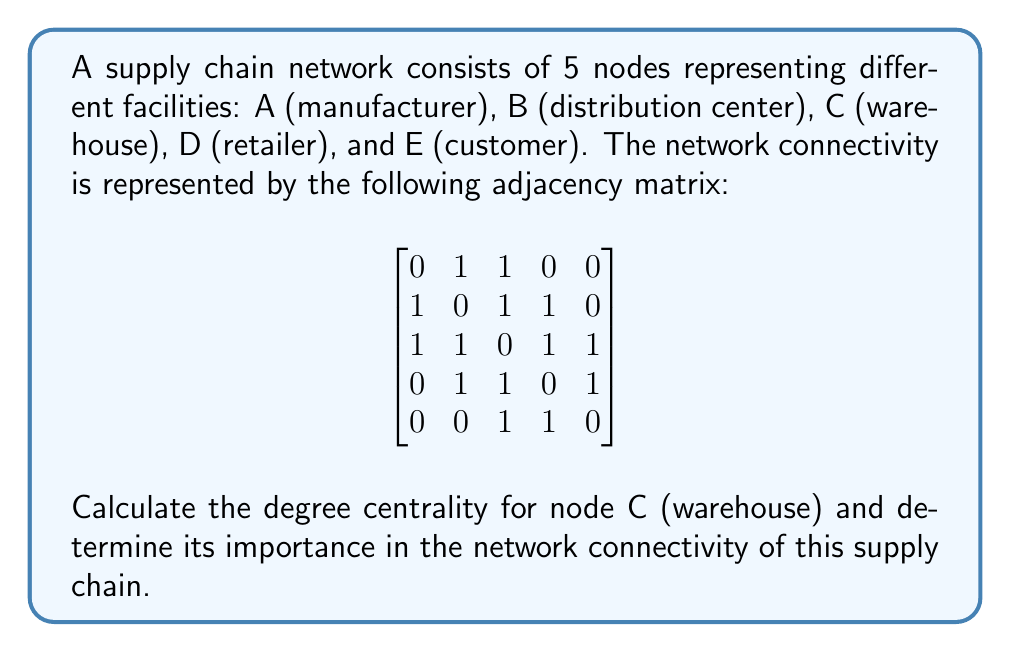Help me with this question. To solve this problem, we need to understand the concept of degree centrality in network analysis and how it applies to supply chain logistics. Here's a step-by-step explanation:

1. Degree centrality is a measure of the number of direct connections a node has in a network. It indicates how central or important a node is based on its direct connections.

2. In an undirected network (which is the case here, as the adjacency matrix is symmetric), the degree centrality of a node is calculated by summing up the number of connections it has to other nodes.

3. To find the degree centrality of node C (warehouse), we need to count the number of 1's in the third row (or column, since the matrix is symmetric) of the adjacency matrix.

4. Looking at the third row/column of the matrix:
   $[1, 1, 0, 1, 1]$

5. We can see that node C has connections to 4 other nodes (A, B, D, and E).

6. The degree centrality of node C is therefore 4.

7. To determine the relative importance of node C, we need to compare its degree centrality to the maximum possible degree centrality in this network.

8. In a network with 5 nodes, the maximum possible degree centrality is 4 (connections to all other nodes except itself).

9. We can calculate the normalized degree centrality by dividing the actual degree centrality by the maximum possible:

   Normalized Degree Centrality = $\frac{\text{Actual Degree Centrality}}{\text{Maximum Possible Degree Centrality}} = \frac{4}{4} = 1$

10. A normalized degree centrality of 1 indicates that node C (warehouse) has the highest possible connectivity in this network, making it a crucial point in the supply chain.
Answer: The degree centrality of node C (warehouse) is 4, and its normalized degree centrality is 1. This indicates that the warehouse is a critical hub in the supply chain network, directly connected to all other facilities except itself, and plays a crucial role in the overall connectivity and flow of goods within the system. 